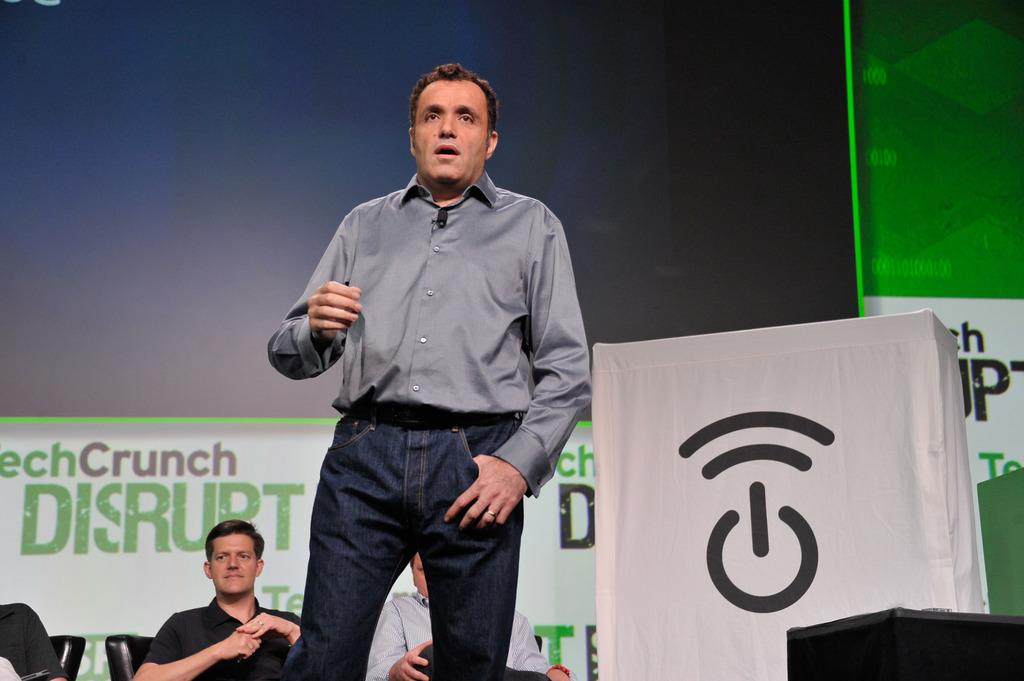What is the man in the image doing? The man is standing at the podium. What can be seen besides the man at the podium? There is an object present in the image. What is happening in the background of the image? There are three men sitting on chairs in the background. What is visible in the far background of the image? There is a hoarding visible in the background. How many cattle can be seen grazing in the image? There are no cattle present in the image. What type of bubble is floating near the man at the podium? There is no bubble present in the image. 